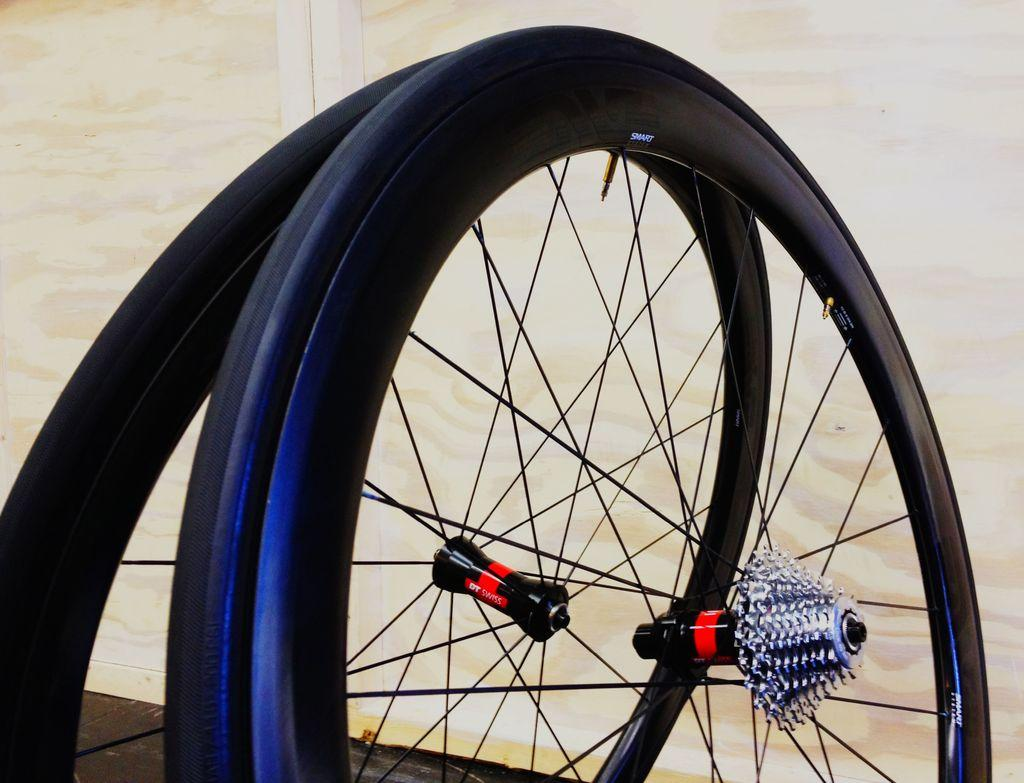What objects are on the floor in the image? There are two wheels on the floor in the image. What type of wall can be seen in the background of the image? There is a wooden wall in the background of the image. How does the duck interact with the water in the image? There is no duck or water present in the image; it only features two wheels on the floor and a wooden wall in the background. 